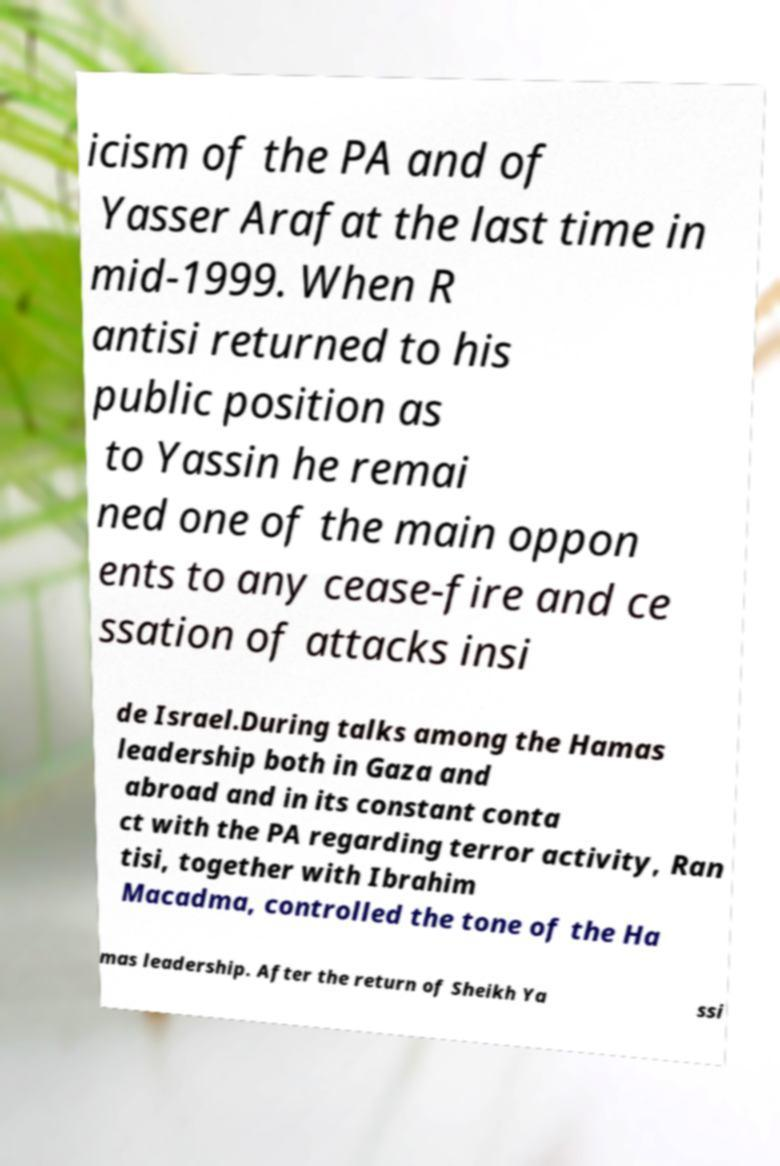For documentation purposes, I need the text within this image transcribed. Could you provide that? icism of the PA and of Yasser Arafat the last time in mid-1999. When R antisi returned to his public position as to Yassin he remai ned one of the main oppon ents to any cease-fire and ce ssation of attacks insi de Israel.During talks among the Hamas leadership both in Gaza and abroad and in its constant conta ct with the PA regarding terror activity, Ran tisi, together with Ibrahim Macadma, controlled the tone of the Ha mas leadership. After the return of Sheikh Ya ssi 